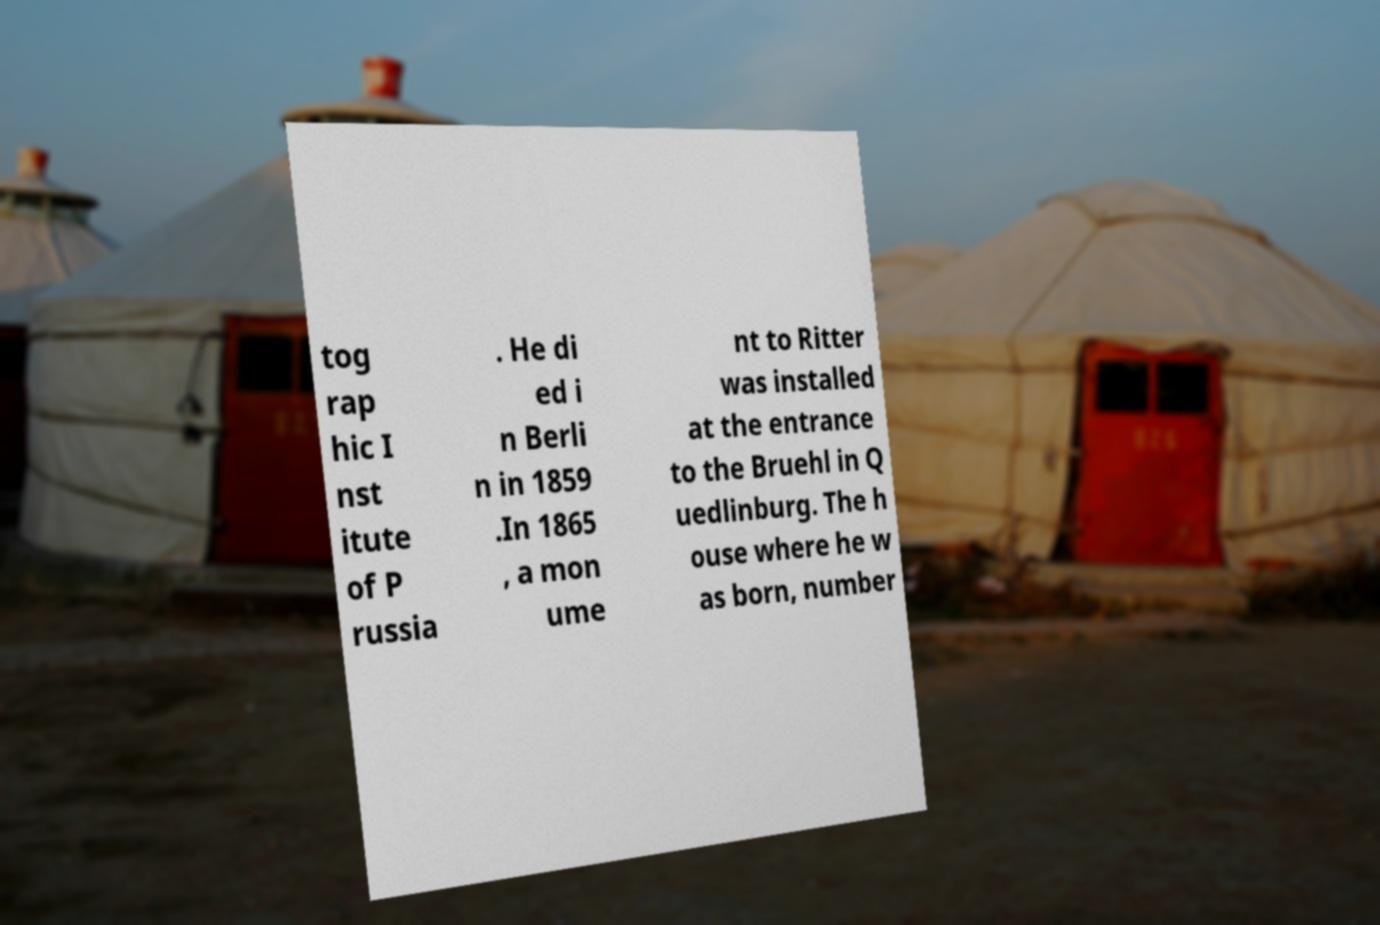Can you read and provide the text displayed in the image?This photo seems to have some interesting text. Can you extract and type it out for me? tog rap hic I nst itute of P russia . He di ed i n Berli n in 1859 .In 1865 , a mon ume nt to Ritter was installed at the entrance to the Bruehl in Q uedlinburg. The h ouse where he w as born, number 